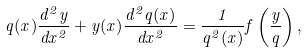Convert formula to latex. <formula><loc_0><loc_0><loc_500><loc_500>q ( x ) \frac { d ^ { 2 } y } { d x ^ { 2 } } + y ( x ) \frac { d ^ { 2 } q ( x ) } { d x ^ { 2 } } = \frac { 1 } { q ^ { 2 } ( x ) } f \left ( \frac { y } { q } \right ) ,</formula> 